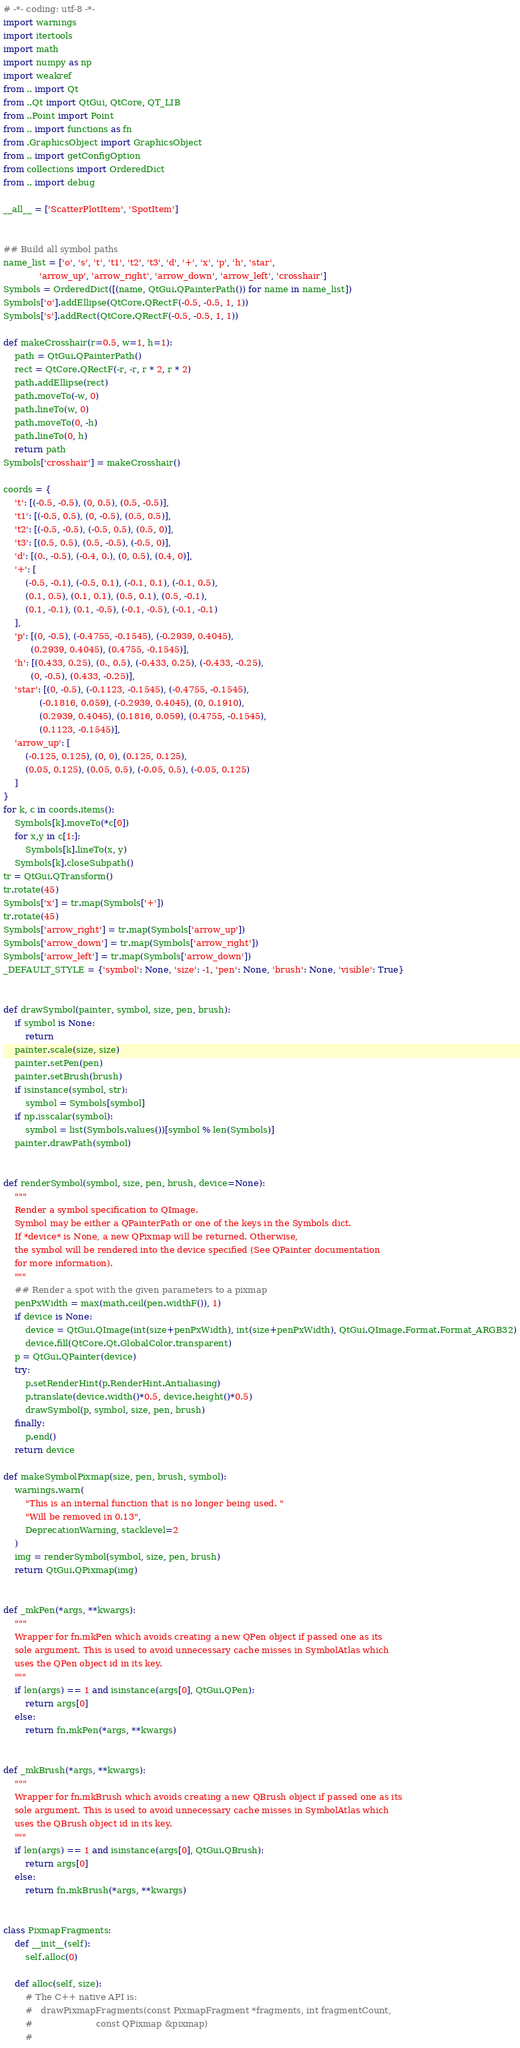Convert code to text. <code><loc_0><loc_0><loc_500><loc_500><_Python_># -*- coding: utf-8 -*-
import warnings
import itertools
import math
import numpy as np
import weakref
from .. import Qt
from ..Qt import QtGui, QtCore, QT_LIB
from ..Point import Point
from .. import functions as fn
from .GraphicsObject import GraphicsObject
from .. import getConfigOption
from collections import OrderedDict
from .. import debug

__all__ = ['ScatterPlotItem', 'SpotItem']


## Build all symbol paths
name_list = ['o', 's', 't', 't1', 't2', 't3', 'd', '+', 'x', 'p', 'h', 'star',
             'arrow_up', 'arrow_right', 'arrow_down', 'arrow_left', 'crosshair']
Symbols = OrderedDict([(name, QtGui.QPainterPath()) for name in name_list])
Symbols['o'].addEllipse(QtCore.QRectF(-0.5, -0.5, 1, 1))
Symbols['s'].addRect(QtCore.QRectF(-0.5, -0.5, 1, 1))

def makeCrosshair(r=0.5, w=1, h=1):
    path = QtGui.QPainterPath()
    rect = QtCore.QRectF(-r, -r, r * 2, r * 2)
    path.addEllipse(rect)
    path.moveTo(-w, 0)
    path.lineTo(w, 0)
    path.moveTo(0, -h)
    path.lineTo(0, h)
    return path
Symbols['crosshair'] = makeCrosshair()

coords = {
    't': [(-0.5, -0.5), (0, 0.5), (0.5, -0.5)],
    't1': [(-0.5, 0.5), (0, -0.5), (0.5, 0.5)],
    't2': [(-0.5, -0.5), (-0.5, 0.5), (0.5, 0)],
    't3': [(0.5, 0.5), (0.5, -0.5), (-0.5, 0)],
    'd': [(0., -0.5), (-0.4, 0.), (0, 0.5), (0.4, 0)],
    '+': [
        (-0.5, -0.1), (-0.5, 0.1), (-0.1, 0.1), (-0.1, 0.5),
        (0.1, 0.5), (0.1, 0.1), (0.5, 0.1), (0.5, -0.1),
        (0.1, -0.1), (0.1, -0.5), (-0.1, -0.5), (-0.1, -0.1)
    ],
    'p': [(0, -0.5), (-0.4755, -0.1545), (-0.2939, 0.4045),
          (0.2939, 0.4045), (0.4755, -0.1545)],
    'h': [(0.433, 0.25), (0., 0.5), (-0.433, 0.25), (-0.433, -0.25),
          (0, -0.5), (0.433, -0.25)],
    'star': [(0, -0.5), (-0.1123, -0.1545), (-0.4755, -0.1545),
             (-0.1816, 0.059), (-0.2939, 0.4045), (0, 0.1910),
             (0.2939, 0.4045), (0.1816, 0.059), (0.4755, -0.1545),
             (0.1123, -0.1545)],
    'arrow_up': [
        (-0.125, 0.125), (0, 0), (0.125, 0.125),
        (0.05, 0.125), (0.05, 0.5), (-0.05, 0.5), (-0.05, 0.125)
    ]
}
for k, c in coords.items():
    Symbols[k].moveTo(*c[0])
    for x,y in c[1:]:
        Symbols[k].lineTo(x, y)
    Symbols[k].closeSubpath()
tr = QtGui.QTransform()
tr.rotate(45)
Symbols['x'] = tr.map(Symbols['+'])
tr.rotate(45)
Symbols['arrow_right'] = tr.map(Symbols['arrow_up'])
Symbols['arrow_down'] = tr.map(Symbols['arrow_right'])
Symbols['arrow_left'] = tr.map(Symbols['arrow_down'])
_DEFAULT_STYLE = {'symbol': None, 'size': -1, 'pen': None, 'brush': None, 'visible': True}


def drawSymbol(painter, symbol, size, pen, brush):
    if symbol is None:
        return
    painter.scale(size, size)
    painter.setPen(pen)
    painter.setBrush(brush)
    if isinstance(symbol, str):
        symbol = Symbols[symbol]
    if np.isscalar(symbol):
        symbol = list(Symbols.values())[symbol % len(Symbols)]
    painter.drawPath(symbol)


def renderSymbol(symbol, size, pen, brush, device=None):
    """
    Render a symbol specification to QImage.
    Symbol may be either a QPainterPath or one of the keys in the Symbols dict.
    If *device* is None, a new QPixmap will be returned. Otherwise,
    the symbol will be rendered into the device specified (See QPainter documentation
    for more information).
    """
    ## Render a spot with the given parameters to a pixmap
    penPxWidth = max(math.ceil(pen.widthF()), 1)
    if device is None:
        device = QtGui.QImage(int(size+penPxWidth), int(size+penPxWidth), QtGui.QImage.Format.Format_ARGB32)
        device.fill(QtCore.Qt.GlobalColor.transparent)
    p = QtGui.QPainter(device)
    try:
        p.setRenderHint(p.RenderHint.Antialiasing)
        p.translate(device.width()*0.5, device.height()*0.5)
        drawSymbol(p, symbol, size, pen, brush)
    finally:
        p.end()
    return device

def makeSymbolPixmap(size, pen, brush, symbol):
    warnings.warn(
        "This is an internal function that is no longer being used. "
        "Will be removed in 0.13",
        DeprecationWarning, stacklevel=2
    )
    img = renderSymbol(symbol, size, pen, brush)
    return QtGui.QPixmap(img)


def _mkPen(*args, **kwargs):
    """
    Wrapper for fn.mkPen which avoids creating a new QPen object if passed one as its
    sole argument. This is used to avoid unnecessary cache misses in SymbolAtlas which
    uses the QPen object id in its key.
    """
    if len(args) == 1 and isinstance(args[0], QtGui.QPen):
        return args[0]
    else:
        return fn.mkPen(*args, **kwargs)


def _mkBrush(*args, **kwargs):
    """
    Wrapper for fn.mkBrush which avoids creating a new QBrush object if passed one as its
    sole argument. This is used to avoid unnecessary cache misses in SymbolAtlas which
    uses the QBrush object id in its key.
    """
    if len(args) == 1 and isinstance(args[0], QtGui.QBrush):
        return args[0]
    else:
        return fn.mkBrush(*args, **kwargs)


class PixmapFragments:
    def __init__(self):
        self.alloc(0)

    def alloc(self, size):
        # The C++ native API is:
        #   drawPixmapFragments(const PixmapFragment *fragments, int fragmentCount,
        #                       const QPixmap &pixmap)
        #</code> 